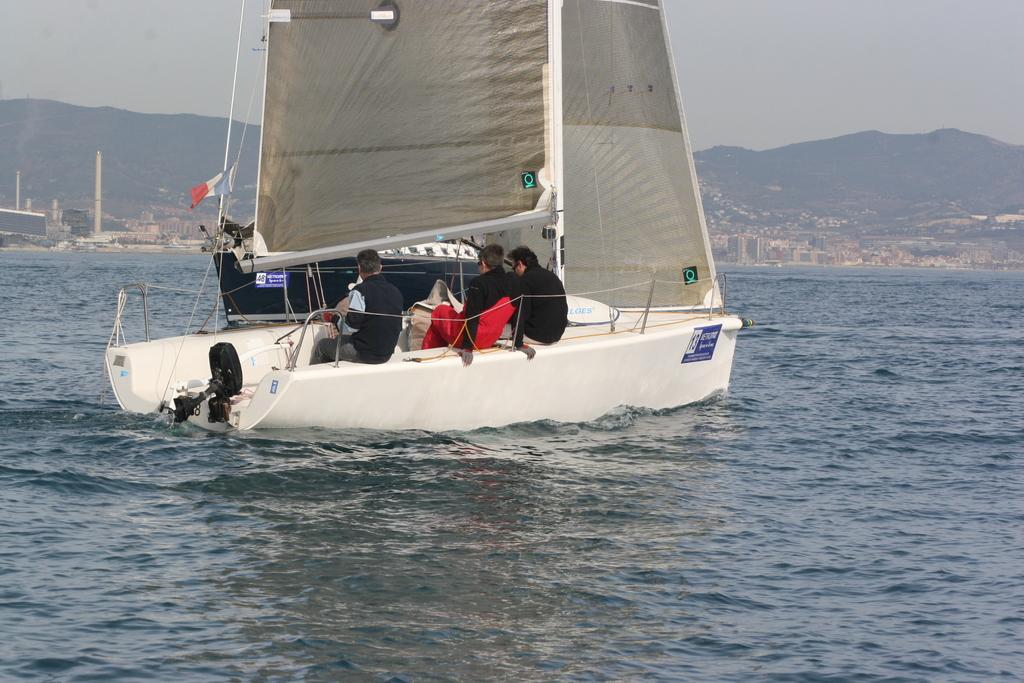How many boys are in the image? There are three boys in the image. What are the boys doing in the image? The boys are sitting in a white sailing boat. What type of water can be seen in the image? There is sea water visible in the image. What can be seen in the distance in the image? There are buildings and mountains in the background of the image. What part of the brain can be seen in the image? There is no part of the brain visible in the image; it features three boys in a sailing boat on the sea. 